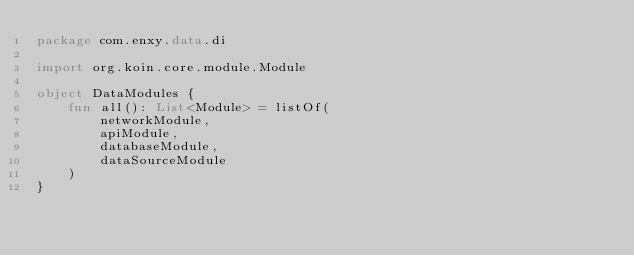Convert code to text. <code><loc_0><loc_0><loc_500><loc_500><_Kotlin_>package com.enxy.data.di

import org.koin.core.module.Module

object DataModules {
    fun all(): List<Module> = listOf(
        networkModule,
        apiModule,
        databaseModule,
        dataSourceModule
    )
}
</code> 